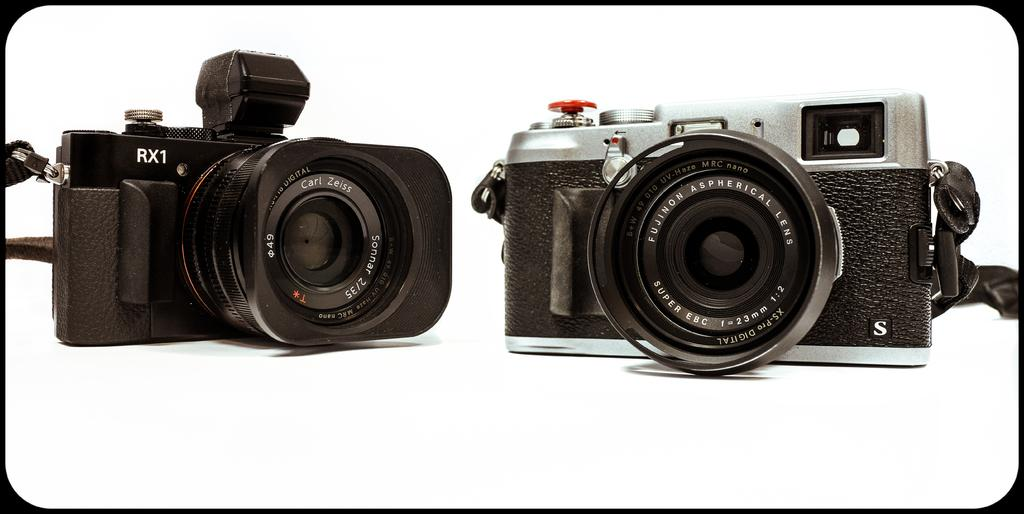What objects are present in the image related to photography? There are two cameras in the image. What feature do the cameras have in common? The cameras have lenses. What else can be seen in the image besides the cameras? There is text visible in the image. What color is the surface that the cameras are placed on? There is a white surface in the image. What type of screw is being used to adjust the operation of the cameras in the image? There is no screw or operation being performed on the cameras in the image; they are simply sitting on a white surface with their lenses visible. 